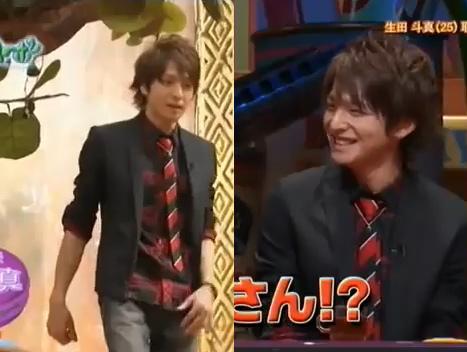What age range is this person?
Keep it brief. 12-14. Were these pictures taken on the same day?
Write a very short answer. Yes. What color is his tie?
Concise answer only. Red and black. What is the name of the president?
Quick response, please. Obama. What is the singer doing?
Keep it brief. Smiling. Is the coat featured double-breasted?
Short answer required. No. Does he have something clipped on his jacket?
Be succinct. Yes. What color is the man's tie?
Be succinct. Red. 